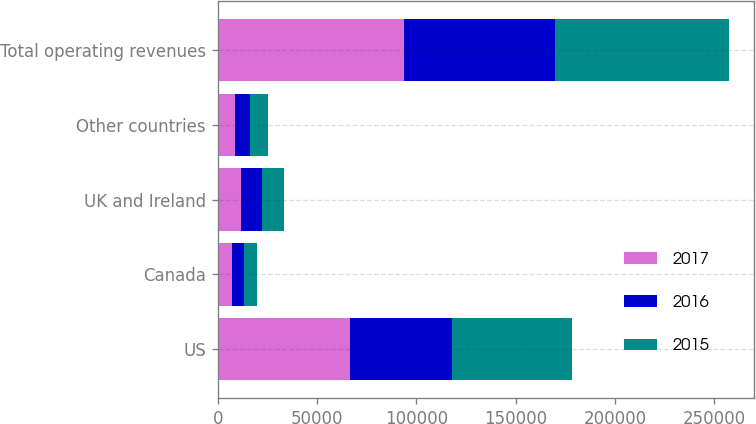Convert chart. <chart><loc_0><loc_0><loc_500><loc_500><stacked_bar_chart><ecel><fcel>US<fcel>Canada<fcel>UK and Ireland<fcel>Other countries<fcel>Total operating revenues<nl><fcel>2017<fcel>66614<fcel>7039<fcel>11556<fcel>8771<fcel>93980<nl><fcel>2016<fcel>51479<fcel>6115<fcel>10797<fcel>7268<fcel>75659<nl><fcel>2015<fcel>60319<fcel>6841<fcel>11232<fcel>9412<fcel>87804<nl></chart> 